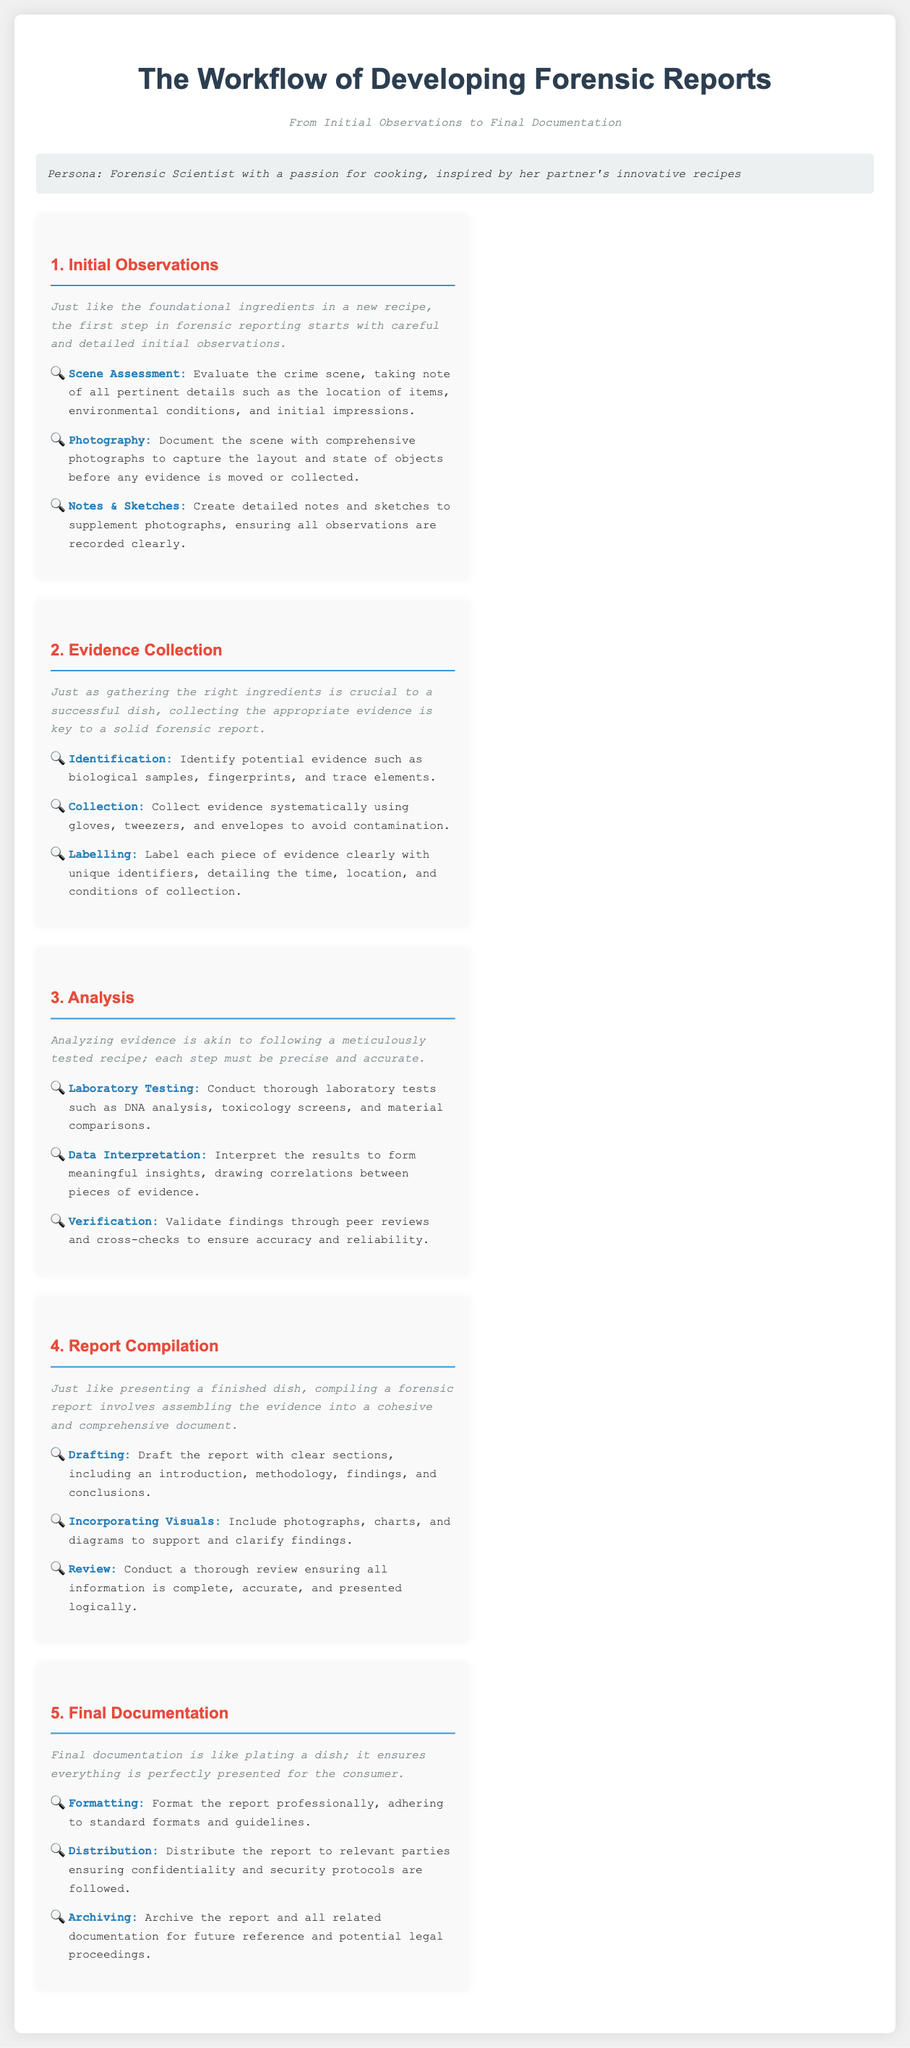What is the title of the workflow? The title can be found at the top of the document and summarizes the main topic of the infographic.
Answer: The Workflow of Developing Forensic Reports What step follows Initial Observations? The steps in the workflow are sequentially numbered, each representing a phase in the process.
Answer: Evidence Collection How many steps are there in the Analysis section? The number of steps can be counted based on the bullet points listed under the Analysis section.
Answer: Three What descriptive analogy is used in the Evidence Collection section? The section uses an analogy that compares a forensic process to an everyday activity to enhance understanding.
Answer: Gathering the right ingredients What is the final step in the workflow? By checking the sequence of the steps, we can identify the last step that concludes the workflow process.
Answer: Final Documentation What is the purpose of incorporating visuals in the Report Compilation section? This purpose is described in the section, indicating the role visuals play in supporting the report.
Answer: To support and clarify findings What is needed for the Laboration Testing step? The specifics for what is required during this step are outlined in the document.
Answer: Laboratory tests What action is completed after Distribution in the Final Documentation section? The actions are listed in sequence, indicating what occurs following Distribution.
Answer: Archiving What font style is used for the section titles? The document clarifies the font characteristics used for different text elements throughout the workflow.
Answer: Arial, sans-serif 